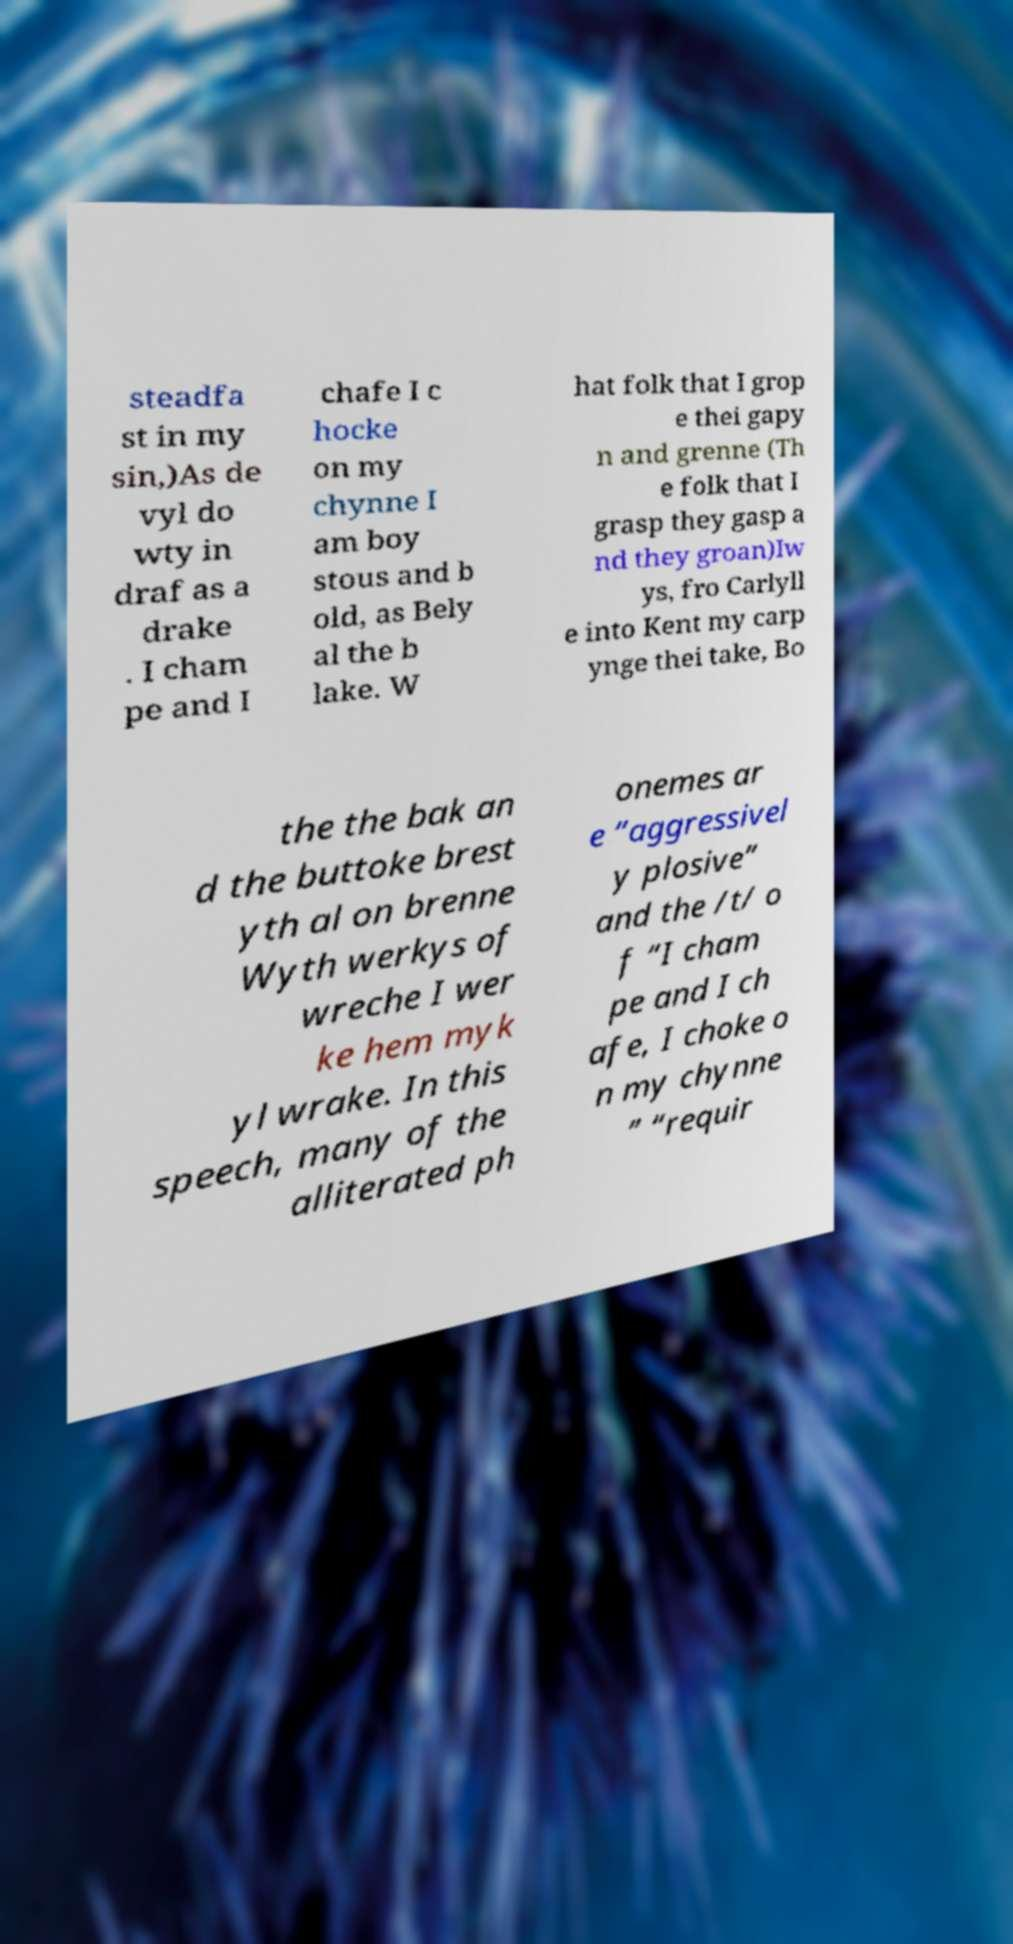What messages or text are displayed in this image? I need them in a readable, typed format. steadfa st in my sin,)As de vyl do wty in draf as a drake . I cham pe and I chafe I c hocke on my chynne I am boy stous and b old, as Bely al the b lake. W hat folk that I grop e thei gapy n and grenne (Th e folk that I grasp they gasp a nd they groan)Iw ys, fro Carlyll e into Kent my carp ynge thei take, Bo the the bak an d the buttoke brest yth al on brenne Wyth werkys of wreche I wer ke hem myk yl wrake. In this speech, many of the alliterated ph onemes ar e “aggressivel y plosive” and the /t/ o f “I cham pe and I ch afe, I choke o n my chynne ” “requir 